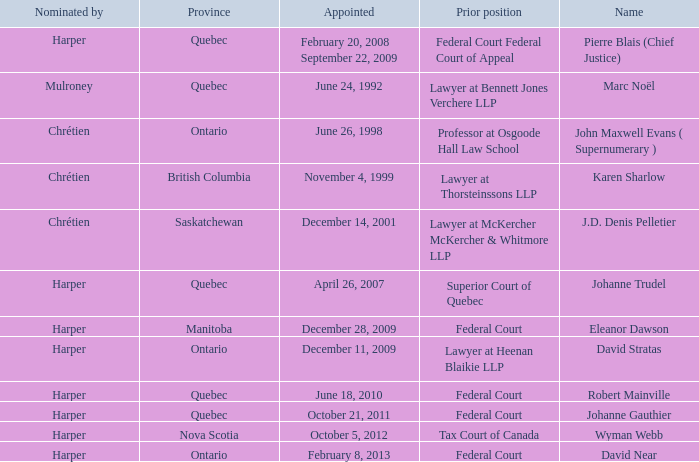Who was appointed on October 21, 2011 from Quebec? Johanne Gauthier. 